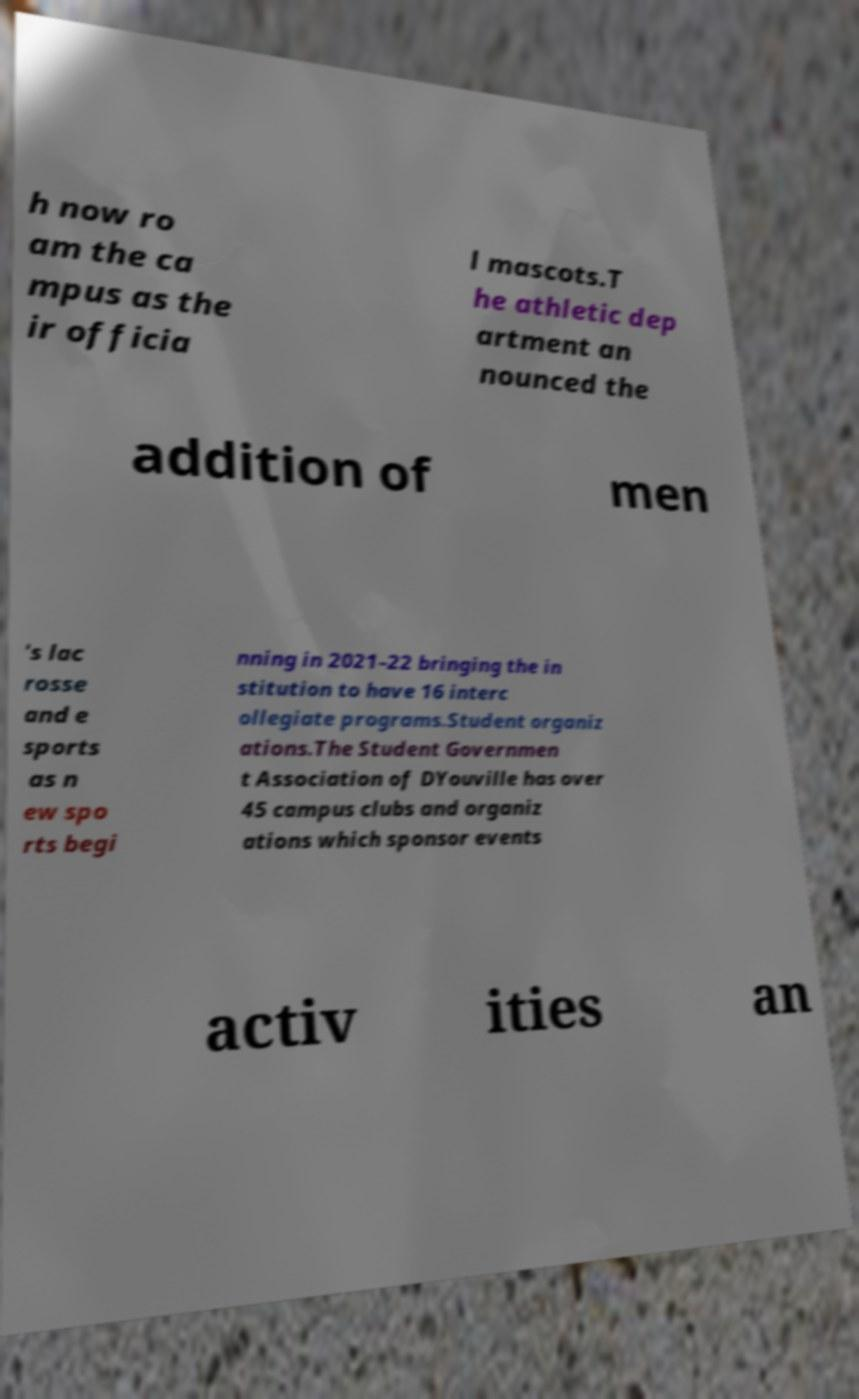Could you assist in decoding the text presented in this image and type it out clearly? h now ro am the ca mpus as the ir officia l mascots.T he athletic dep artment an nounced the addition of men 's lac rosse and e sports as n ew spo rts begi nning in 2021–22 bringing the in stitution to have 16 interc ollegiate programs.Student organiz ations.The Student Governmen t Association of DYouville has over 45 campus clubs and organiz ations which sponsor events activ ities an 